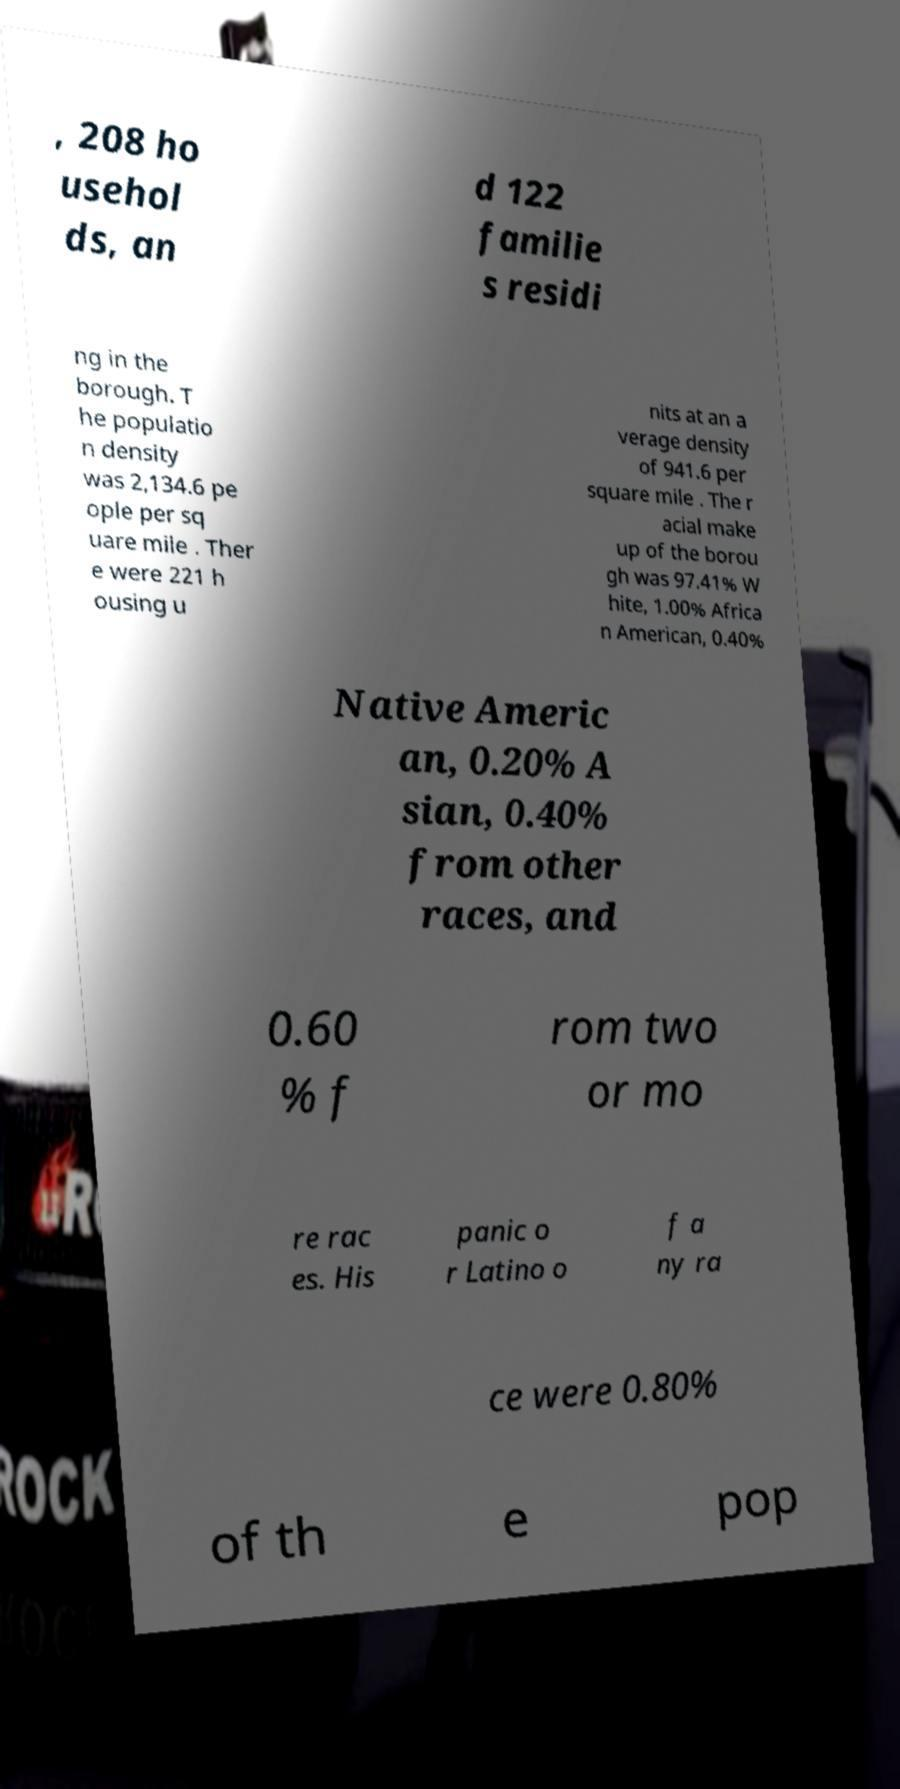Can you accurately transcribe the text from the provided image for me? , 208 ho usehol ds, an d 122 familie s residi ng in the borough. T he populatio n density was 2,134.6 pe ople per sq uare mile . Ther e were 221 h ousing u nits at an a verage density of 941.6 per square mile . The r acial make up of the borou gh was 97.41% W hite, 1.00% Africa n American, 0.40% Native Americ an, 0.20% A sian, 0.40% from other races, and 0.60 % f rom two or mo re rac es. His panic o r Latino o f a ny ra ce were 0.80% of th e pop 